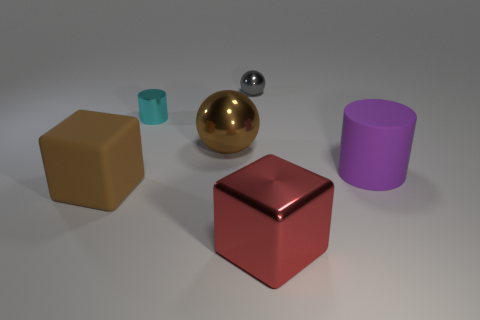Add 3 red metal cubes. How many objects exist? 9 Subtract all cylinders. How many objects are left? 4 Add 1 gray cubes. How many gray cubes exist? 1 Subtract 0 gray cylinders. How many objects are left? 6 Subtract all large yellow balls. Subtract all big rubber cylinders. How many objects are left? 5 Add 2 small gray spheres. How many small gray spheres are left? 3 